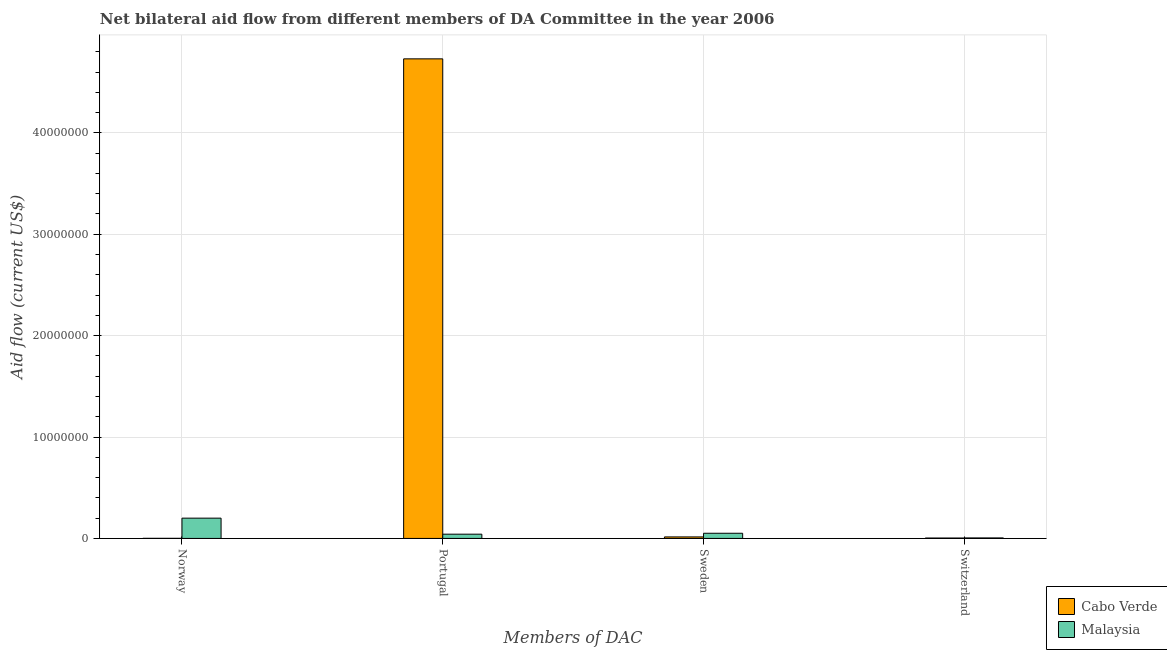How many different coloured bars are there?
Offer a very short reply. 2. Are the number of bars per tick equal to the number of legend labels?
Your answer should be compact. Yes. Are the number of bars on each tick of the X-axis equal?
Your answer should be very brief. Yes. How many bars are there on the 3rd tick from the left?
Your answer should be compact. 2. How many bars are there on the 3rd tick from the right?
Provide a short and direct response. 2. What is the label of the 4th group of bars from the left?
Provide a succinct answer. Switzerland. What is the amount of aid given by norway in Cabo Verde?
Your answer should be compact. 10000. Across all countries, what is the maximum amount of aid given by switzerland?
Your answer should be compact. 5.00e+04. Across all countries, what is the minimum amount of aid given by switzerland?
Provide a short and direct response. 4.00e+04. In which country was the amount of aid given by portugal maximum?
Provide a succinct answer. Cabo Verde. In which country was the amount of aid given by norway minimum?
Keep it short and to the point. Cabo Verde. What is the total amount of aid given by switzerland in the graph?
Give a very brief answer. 9.00e+04. What is the difference between the amount of aid given by norway in Malaysia and that in Cabo Verde?
Ensure brevity in your answer.  1.99e+06. What is the difference between the amount of aid given by switzerland in Malaysia and the amount of aid given by norway in Cabo Verde?
Make the answer very short. 4.00e+04. What is the average amount of aid given by portugal per country?
Make the answer very short. 2.39e+07. What is the difference between the amount of aid given by switzerland and amount of aid given by sweden in Malaysia?
Your answer should be compact. -4.60e+05. What is the ratio of the amount of aid given by portugal in Malaysia to that in Cabo Verde?
Make the answer very short. 0.01. Is the amount of aid given by portugal in Malaysia less than that in Cabo Verde?
Make the answer very short. Yes. What is the difference between the highest and the second highest amount of aid given by switzerland?
Your answer should be compact. 10000. What is the difference between the highest and the lowest amount of aid given by switzerland?
Provide a succinct answer. 10000. Is the sum of the amount of aid given by sweden in Malaysia and Cabo Verde greater than the maximum amount of aid given by norway across all countries?
Offer a very short reply. No. Is it the case that in every country, the sum of the amount of aid given by switzerland and amount of aid given by portugal is greater than the sum of amount of aid given by norway and amount of aid given by sweden?
Make the answer very short. No. What does the 1st bar from the left in Portugal represents?
Your response must be concise. Cabo Verde. What does the 2nd bar from the right in Norway represents?
Provide a short and direct response. Cabo Verde. Is it the case that in every country, the sum of the amount of aid given by norway and amount of aid given by portugal is greater than the amount of aid given by sweden?
Provide a succinct answer. Yes. How many bars are there?
Provide a succinct answer. 8. How many countries are there in the graph?
Provide a succinct answer. 2. What is the difference between two consecutive major ticks on the Y-axis?
Offer a very short reply. 1.00e+07. Are the values on the major ticks of Y-axis written in scientific E-notation?
Give a very brief answer. No. Does the graph contain any zero values?
Offer a very short reply. No. Does the graph contain grids?
Make the answer very short. Yes. What is the title of the graph?
Offer a terse response. Net bilateral aid flow from different members of DA Committee in the year 2006. Does "Turkmenistan" appear as one of the legend labels in the graph?
Keep it short and to the point. No. What is the label or title of the X-axis?
Your response must be concise. Members of DAC. What is the Aid flow (current US$) of Cabo Verde in Portugal?
Your answer should be compact. 4.73e+07. What is the Aid flow (current US$) of Malaysia in Portugal?
Provide a succinct answer. 4.20e+05. What is the Aid flow (current US$) of Cabo Verde in Sweden?
Your answer should be very brief. 1.50e+05. What is the Aid flow (current US$) of Malaysia in Sweden?
Offer a terse response. 5.10e+05. Across all Members of DAC, what is the maximum Aid flow (current US$) of Cabo Verde?
Provide a short and direct response. 4.73e+07. Across all Members of DAC, what is the maximum Aid flow (current US$) in Malaysia?
Your answer should be compact. 2.00e+06. Across all Members of DAC, what is the minimum Aid flow (current US$) of Malaysia?
Offer a terse response. 5.00e+04. What is the total Aid flow (current US$) of Cabo Verde in the graph?
Keep it short and to the point. 4.75e+07. What is the total Aid flow (current US$) of Malaysia in the graph?
Your response must be concise. 2.98e+06. What is the difference between the Aid flow (current US$) in Cabo Verde in Norway and that in Portugal?
Provide a short and direct response. -4.73e+07. What is the difference between the Aid flow (current US$) in Malaysia in Norway and that in Portugal?
Your response must be concise. 1.58e+06. What is the difference between the Aid flow (current US$) in Malaysia in Norway and that in Sweden?
Your answer should be compact. 1.49e+06. What is the difference between the Aid flow (current US$) in Malaysia in Norway and that in Switzerland?
Provide a short and direct response. 1.95e+06. What is the difference between the Aid flow (current US$) of Cabo Verde in Portugal and that in Sweden?
Your response must be concise. 4.72e+07. What is the difference between the Aid flow (current US$) of Malaysia in Portugal and that in Sweden?
Give a very brief answer. -9.00e+04. What is the difference between the Aid flow (current US$) in Cabo Verde in Portugal and that in Switzerland?
Your answer should be very brief. 4.73e+07. What is the difference between the Aid flow (current US$) of Cabo Verde in Norway and the Aid flow (current US$) of Malaysia in Portugal?
Offer a terse response. -4.10e+05. What is the difference between the Aid flow (current US$) in Cabo Verde in Norway and the Aid flow (current US$) in Malaysia in Sweden?
Your answer should be compact. -5.00e+05. What is the difference between the Aid flow (current US$) of Cabo Verde in Norway and the Aid flow (current US$) of Malaysia in Switzerland?
Your answer should be compact. -4.00e+04. What is the difference between the Aid flow (current US$) of Cabo Verde in Portugal and the Aid flow (current US$) of Malaysia in Sweden?
Your answer should be compact. 4.68e+07. What is the difference between the Aid flow (current US$) of Cabo Verde in Portugal and the Aid flow (current US$) of Malaysia in Switzerland?
Make the answer very short. 4.72e+07. What is the difference between the Aid flow (current US$) in Cabo Verde in Sweden and the Aid flow (current US$) in Malaysia in Switzerland?
Your response must be concise. 1.00e+05. What is the average Aid flow (current US$) of Cabo Verde per Members of DAC?
Your answer should be compact. 1.19e+07. What is the average Aid flow (current US$) of Malaysia per Members of DAC?
Make the answer very short. 7.45e+05. What is the difference between the Aid flow (current US$) of Cabo Verde and Aid flow (current US$) of Malaysia in Norway?
Offer a terse response. -1.99e+06. What is the difference between the Aid flow (current US$) of Cabo Verde and Aid flow (current US$) of Malaysia in Portugal?
Your answer should be compact. 4.69e+07. What is the difference between the Aid flow (current US$) of Cabo Verde and Aid flow (current US$) of Malaysia in Sweden?
Your answer should be compact. -3.60e+05. What is the difference between the Aid flow (current US$) of Cabo Verde and Aid flow (current US$) of Malaysia in Switzerland?
Provide a succinct answer. -10000. What is the ratio of the Aid flow (current US$) in Cabo Verde in Norway to that in Portugal?
Keep it short and to the point. 0. What is the ratio of the Aid flow (current US$) of Malaysia in Norway to that in Portugal?
Offer a very short reply. 4.76. What is the ratio of the Aid flow (current US$) of Cabo Verde in Norway to that in Sweden?
Your response must be concise. 0.07. What is the ratio of the Aid flow (current US$) in Malaysia in Norway to that in Sweden?
Your response must be concise. 3.92. What is the ratio of the Aid flow (current US$) in Malaysia in Norway to that in Switzerland?
Make the answer very short. 40. What is the ratio of the Aid flow (current US$) of Cabo Verde in Portugal to that in Sweden?
Your answer should be compact. 315.33. What is the ratio of the Aid flow (current US$) in Malaysia in Portugal to that in Sweden?
Provide a short and direct response. 0.82. What is the ratio of the Aid flow (current US$) in Cabo Verde in Portugal to that in Switzerland?
Keep it short and to the point. 1182.5. What is the ratio of the Aid flow (current US$) in Malaysia in Portugal to that in Switzerland?
Your answer should be compact. 8.4. What is the ratio of the Aid flow (current US$) in Cabo Verde in Sweden to that in Switzerland?
Your response must be concise. 3.75. What is the ratio of the Aid flow (current US$) of Malaysia in Sweden to that in Switzerland?
Your response must be concise. 10.2. What is the difference between the highest and the second highest Aid flow (current US$) of Cabo Verde?
Keep it short and to the point. 4.72e+07. What is the difference between the highest and the second highest Aid flow (current US$) in Malaysia?
Provide a short and direct response. 1.49e+06. What is the difference between the highest and the lowest Aid flow (current US$) in Cabo Verde?
Your response must be concise. 4.73e+07. What is the difference between the highest and the lowest Aid flow (current US$) in Malaysia?
Keep it short and to the point. 1.95e+06. 